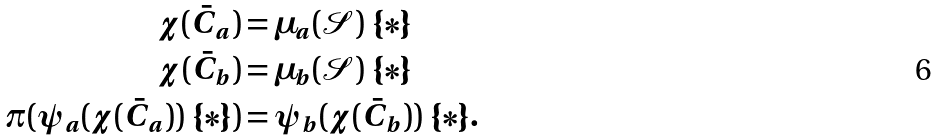Convert formula to latex. <formula><loc_0><loc_0><loc_500><loc_500>\chi ( \bar { C } _ { a } ) & = \mu _ { a } ( \mathcal { S } ) \ \{ \ast \} \\ \chi ( \bar { C } _ { b } ) & = \mu _ { b } ( \mathcal { S } ) \ \{ \ast \} \\ \pi ( \psi _ { a } ( \chi ( \bar { C } _ { a } ) ) \ \{ \ast \} ) & = \psi _ { b } ( \chi ( \bar { C } _ { b } ) ) \ \{ \ast \} .</formula> 